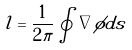<formula> <loc_0><loc_0><loc_500><loc_500>l = \frac { 1 } { 2 \pi } \oint \nabla \phi d s</formula> 